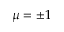Convert formula to latex. <formula><loc_0><loc_0><loc_500><loc_500>\mu = \pm 1</formula> 